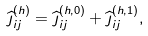<formula> <loc_0><loc_0><loc_500><loc_500>\widehat { \jmath } _ { i j } ^ { ( h ) } = \widehat { \jmath } _ { i j } ^ { ( h , 0 ) } + \widehat { \jmath } _ { i j } ^ { ( h , 1 ) } ,</formula> 